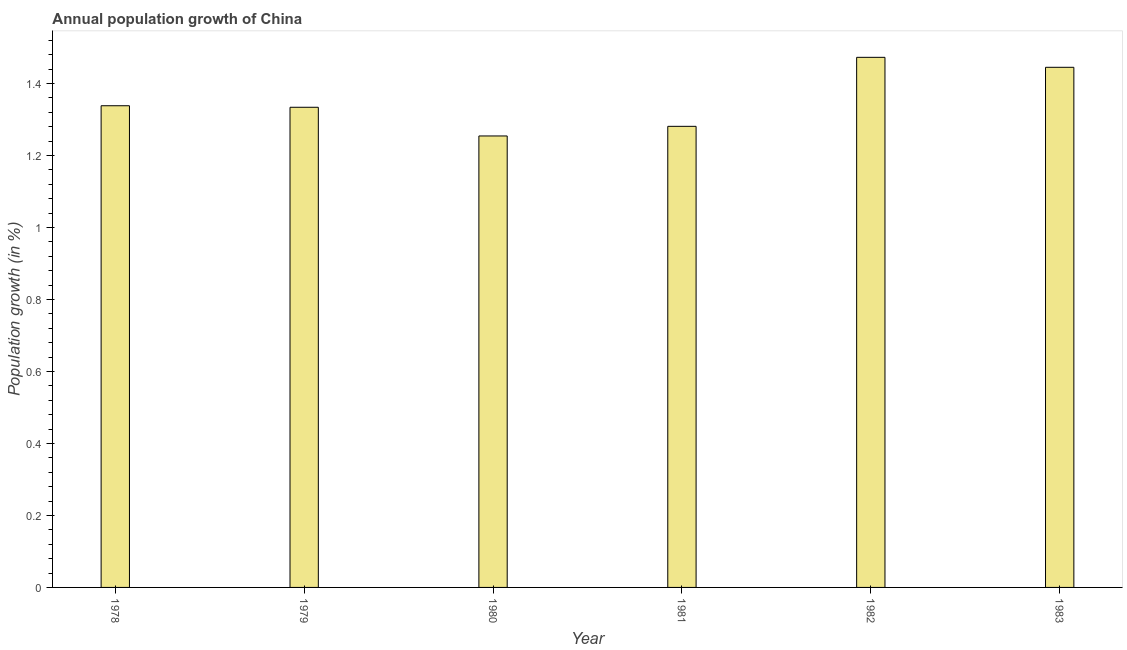What is the title of the graph?
Give a very brief answer. Annual population growth of China. What is the label or title of the Y-axis?
Offer a terse response. Population growth (in %). What is the population growth in 1982?
Provide a succinct answer. 1.47. Across all years, what is the maximum population growth?
Provide a succinct answer. 1.47. Across all years, what is the minimum population growth?
Offer a very short reply. 1.25. What is the sum of the population growth?
Ensure brevity in your answer.  8.12. What is the difference between the population growth in 1982 and 1983?
Keep it short and to the point. 0.03. What is the average population growth per year?
Your answer should be very brief. 1.35. What is the median population growth?
Give a very brief answer. 1.34. Do a majority of the years between 1979 and 1981 (inclusive) have population growth greater than 0.36 %?
Your answer should be compact. Yes. What is the ratio of the population growth in 1979 to that in 1983?
Your answer should be very brief. 0.92. Is the population growth in 1979 less than that in 1982?
Offer a terse response. Yes. Is the difference between the population growth in 1982 and 1983 greater than the difference between any two years?
Give a very brief answer. No. What is the difference between the highest and the second highest population growth?
Your answer should be very brief. 0.03. Is the sum of the population growth in 1981 and 1982 greater than the maximum population growth across all years?
Your response must be concise. Yes. What is the difference between the highest and the lowest population growth?
Your answer should be very brief. 0.22. In how many years, is the population growth greater than the average population growth taken over all years?
Offer a terse response. 2. How many bars are there?
Make the answer very short. 6. Are all the bars in the graph horizontal?
Your response must be concise. No. What is the difference between two consecutive major ticks on the Y-axis?
Provide a succinct answer. 0.2. What is the Population growth (in %) in 1978?
Make the answer very short. 1.34. What is the Population growth (in %) in 1979?
Your answer should be very brief. 1.33. What is the Population growth (in %) of 1980?
Your response must be concise. 1.25. What is the Population growth (in %) of 1981?
Give a very brief answer. 1.28. What is the Population growth (in %) in 1982?
Offer a terse response. 1.47. What is the Population growth (in %) of 1983?
Keep it short and to the point. 1.44. What is the difference between the Population growth (in %) in 1978 and 1979?
Offer a terse response. 0. What is the difference between the Population growth (in %) in 1978 and 1980?
Your answer should be compact. 0.08. What is the difference between the Population growth (in %) in 1978 and 1981?
Keep it short and to the point. 0.06. What is the difference between the Population growth (in %) in 1978 and 1982?
Your answer should be very brief. -0.13. What is the difference between the Population growth (in %) in 1978 and 1983?
Ensure brevity in your answer.  -0.11. What is the difference between the Population growth (in %) in 1979 and 1980?
Your answer should be very brief. 0.08. What is the difference between the Population growth (in %) in 1979 and 1981?
Provide a short and direct response. 0.05. What is the difference between the Population growth (in %) in 1979 and 1982?
Give a very brief answer. -0.14. What is the difference between the Population growth (in %) in 1979 and 1983?
Keep it short and to the point. -0.11. What is the difference between the Population growth (in %) in 1980 and 1981?
Make the answer very short. -0.03. What is the difference between the Population growth (in %) in 1980 and 1982?
Your answer should be compact. -0.22. What is the difference between the Population growth (in %) in 1980 and 1983?
Make the answer very short. -0.19. What is the difference between the Population growth (in %) in 1981 and 1982?
Provide a succinct answer. -0.19. What is the difference between the Population growth (in %) in 1981 and 1983?
Your answer should be very brief. -0.16. What is the difference between the Population growth (in %) in 1982 and 1983?
Provide a short and direct response. 0.03. What is the ratio of the Population growth (in %) in 1978 to that in 1980?
Your answer should be compact. 1.07. What is the ratio of the Population growth (in %) in 1978 to that in 1981?
Offer a very short reply. 1.04. What is the ratio of the Population growth (in %) in 1978 to that in 1982?
Give a very brief answer. 0.91. What is the ratio of the Population growth (in %) in 1978 to that in 1983?
Your response must be concise. 0.93. What is the ratio of the Population growth (in %) in 1979 to that in 1980?
Your answer should be very brief. 1.06. What is the ratio of the Population growth (in %) in 1979 to that in 1981?
Your answer should be compact. 1.04. What is the ratio of the Population growth (in %) in 1979 to that in 1982?
Your answer should be compact. 0.91. What is the ratio of the Population growth (in %) in 1979 to that in 1983?
Keep it short and to the point. 0.92. What is the ratio of the Population growth (in %) in 1980 to that in 1982?
Offer a terse response. 0.85. What is the ratio of the Population growth (in %) in 1980 to that in 1983?
Provide a short and direct response. 0.87. What is the ratio of the Population growth (in %) in 1981 to that in 1982?
Your answer should be very brief. 0.87. What is the ratio of the Population growth (in %) in 1981 to that in 1983?
Your answer should be very brief. 0.89. 